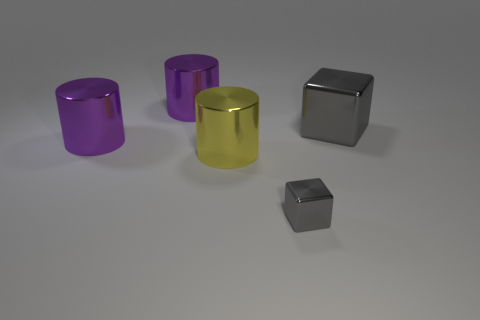There is a metallic block on the left side of the large gray metallic object; how big is it?
Your response must be concise. Small. Are there any purple objects that have the same size as the yellow metallic cylinder?
Offer a very short reply. Yes. There is a cube that is in front of the yellow object; is its size the same as the big yellow cylinder?
Provide a succinct answer. No. There is a metal cube to the left of the gray shiny thing behind the block in front of the big cube; what color is it?
Offer a terse response. Gray. Do the metal cube in front of the large cube and the big block have the same color?
Provide a succinct answer. Yes. How many gray blocks are both in front of the yellow cylinder and behind the yellow metallic cylinder?
Provide a short and direct response. 0. The other gray shiny thing that is the same shape as the big gray thing is what size?
Your answer should be compact. Small. What number of large purple things are on the right side of the large yellow thing that is behind the gray object that is on the left side of the big block?
Your answer should be very brief. 0. What is the color of the large shiny object right of the object in front of the yellow shiny thing?
Provide a succinct answer. Gray. How many other objects are there of the same material as the yellow object?
Offer a terse response. 4. 